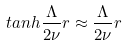<formula> <loc_0><loc_0><loc_500><loc_500>t a n h \frac { \Lambda } { 2 \nu } r \approx \frac { \Lambda } { 2 \nu } r</formula> 